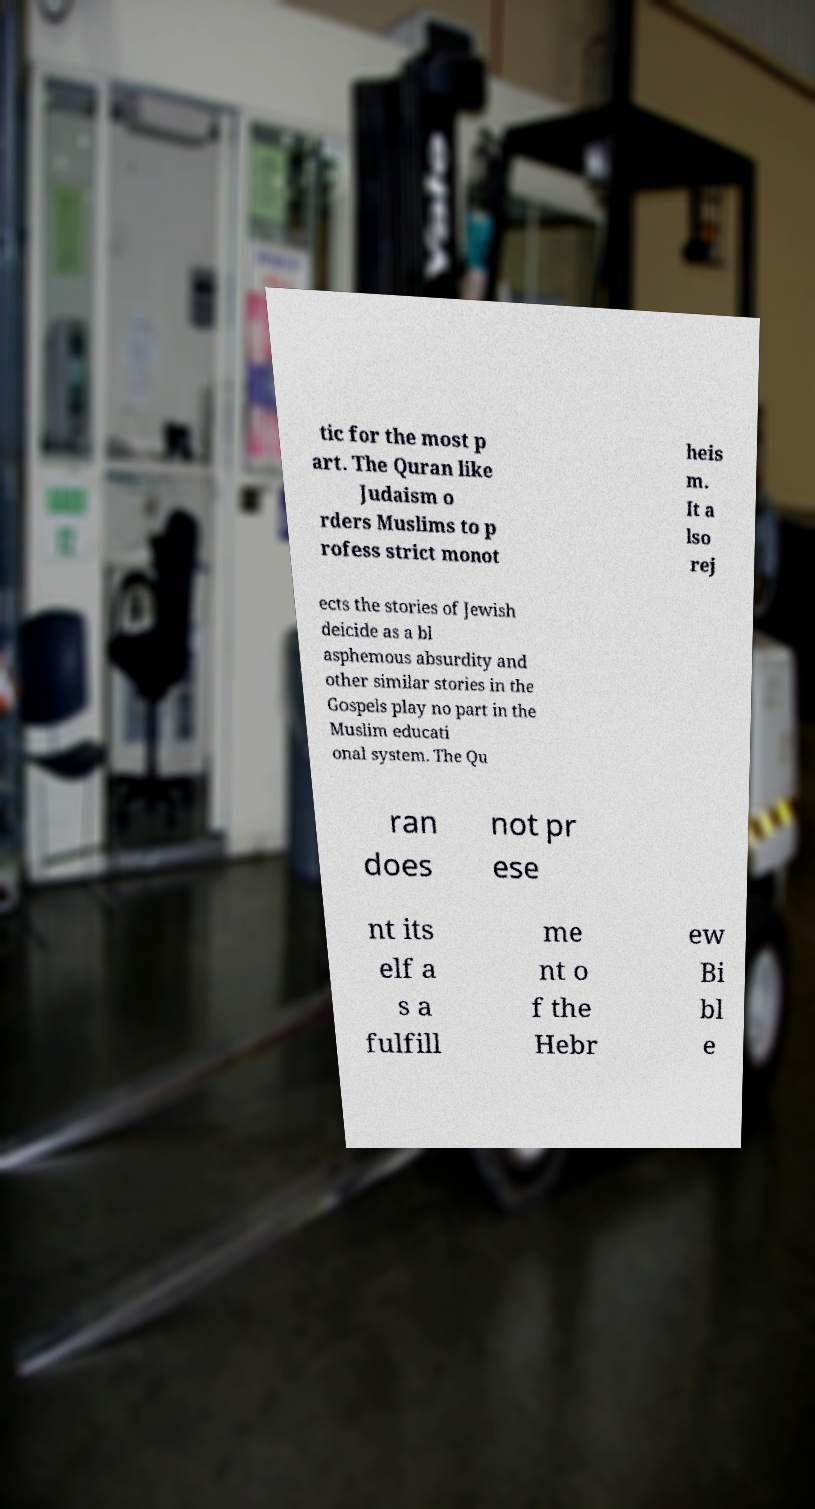Could you assist in decoding the text presented in this image and type it out clearly? tic for the most p art. The Quran like Judaism o rders Muslims to p rofess strict monot heis m. It a lso rej ects the stories of Jewish deicide as a bl asphemous absurdity and other similar stories in the Gospels play no part in the Muslim educati onal system. The Qu ran does not pr ese nt its elf a s a fulfill me nt o f the Hebr ew Bi bl e 